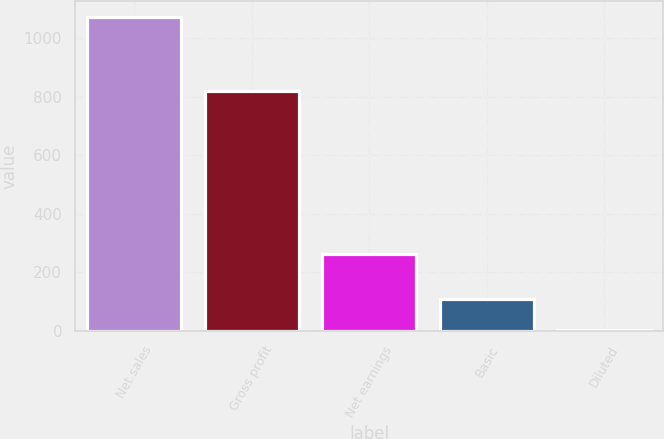Convert chart to OTSL. <chart><loc_0><loc_0><loc_500><loc_500><bar_chart><fcel>Net sales<fcel>Gross profit<fcel>Net earnings<fcel>Basic<fcel>Diluted<nl><fcel>1073.5<fcel>819.6<fcel>263.8<fcel>108.36<fcel>1.12<nl></chart> 